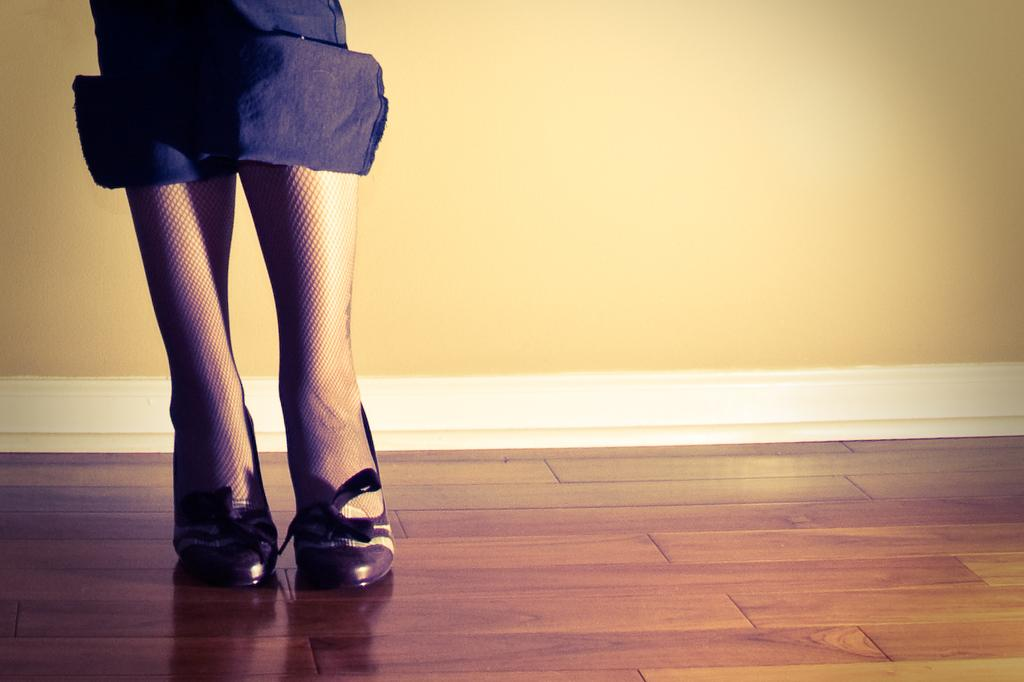Who or what is present in the image? There is a person in the image. What part of the person's body can be seen? The person's legs are visible. What color are the person's trousers? The person is wearing blue color trousers. What type of footwear is the person wearing? The person is wearing shoes. What surface is the person standing on? The person is standing on the floor. What can be seen in the background of the image? There is a wall in the background of the image. What type of pan is being used by the person in the image? There is no pan present in the image; it features a person standing on the floor with visible legs, wearing blue trousers and shoes. 